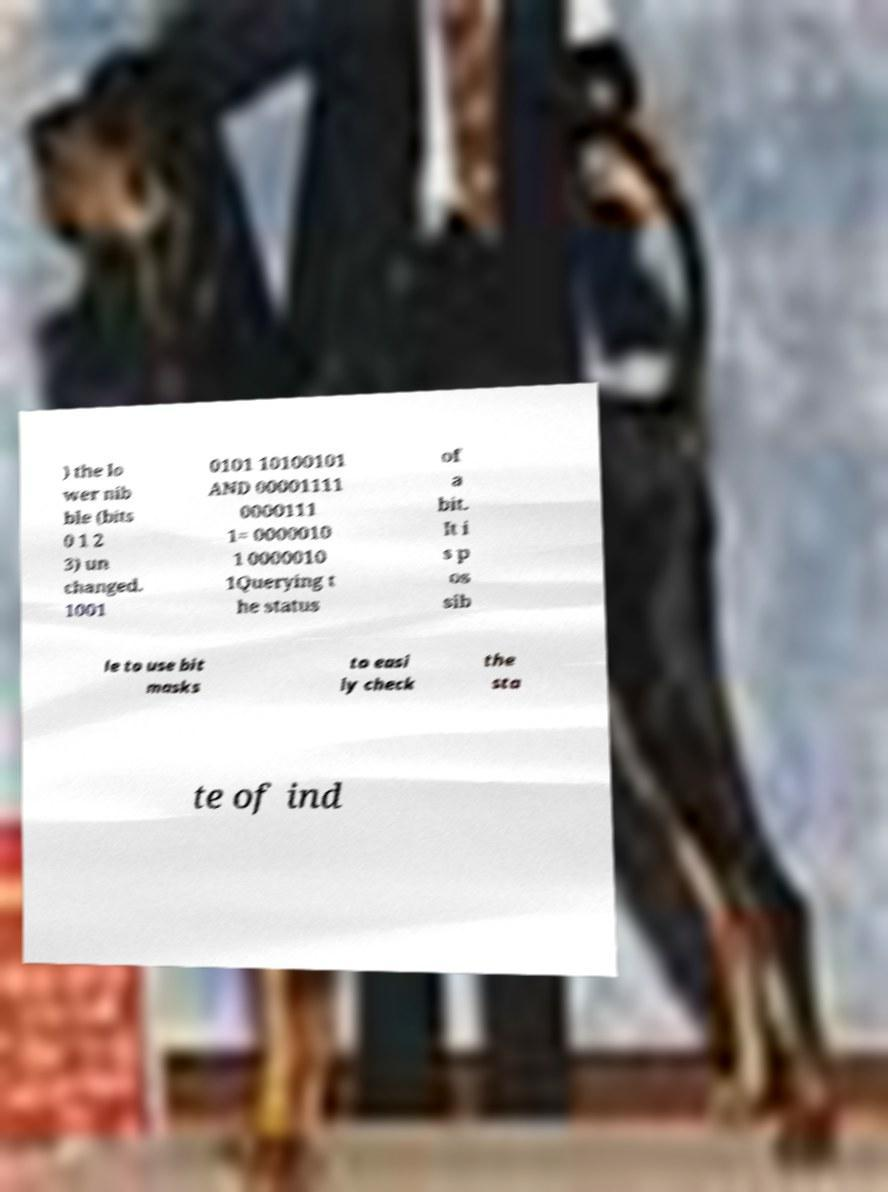I need the written content from this picture converted into text. Can you do that? ) the lo wer nib ble (bits 0 1 2 3) un changed. 1001 0101 10100101 AND 00001111 0000111 1= 0000010 1 0000010 1Querying t he status of a bit. It i s p os sib le to use bit masks to easi ly check the sta te of ind 